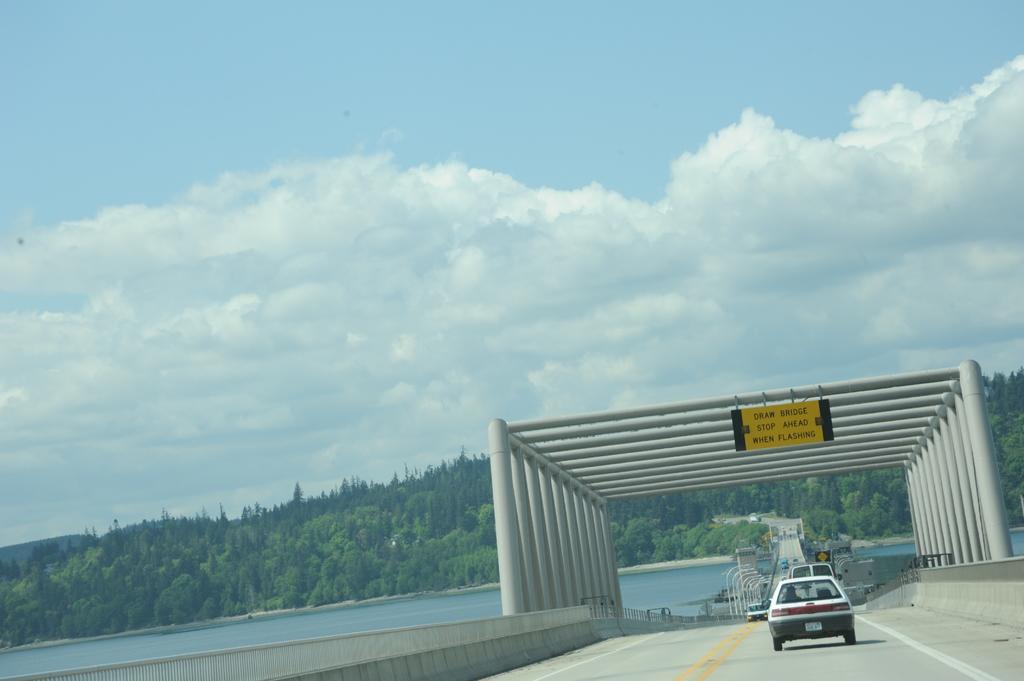Could you give a brief overview of what you see in this image? In this image few cars are on the road. There is an arch over the road. Behind there are few street lights. Behind there is water. Few trees are on the land. Top of image there is sky with some clouds. 